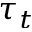Convert formula to latex. <formula><loc_0><loc_0><loc_500><loc_500>\tau _ { t }</formula> 